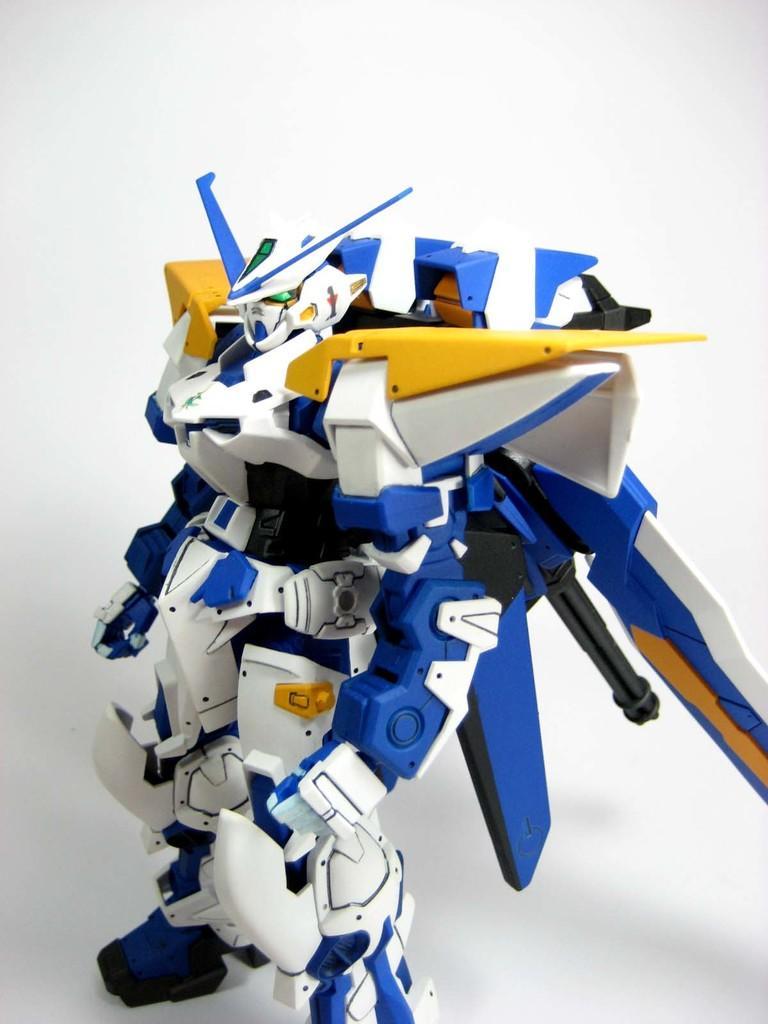How would you summarize this image in a sentence or two? In the center of the image we can see one robot, which is in blue, white and yellow color. In the background there is a wall. 